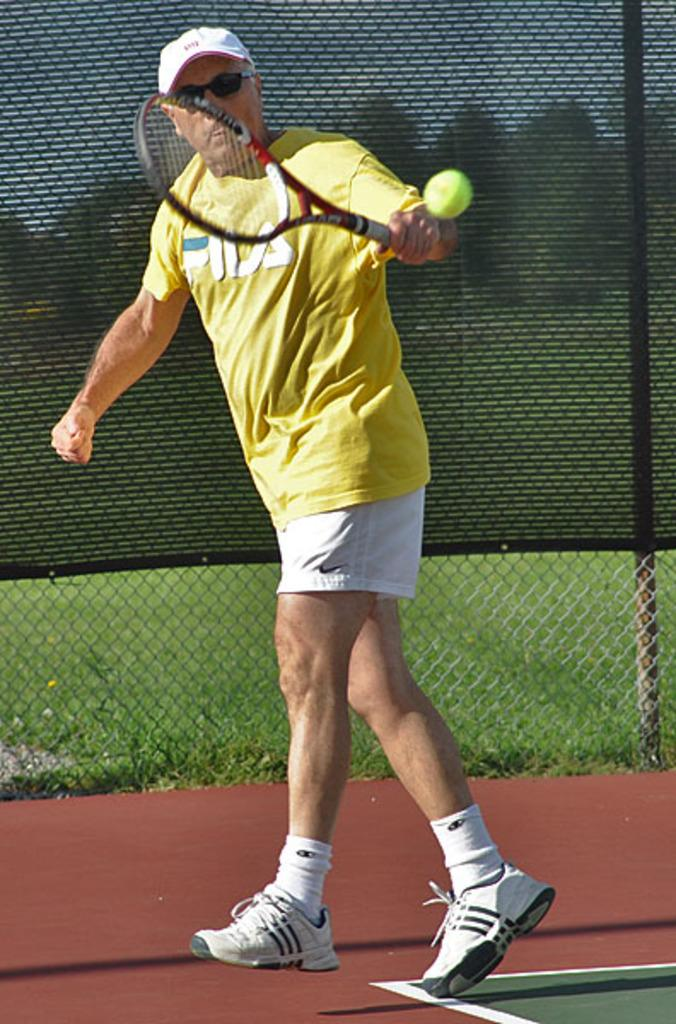What activity is the man in the image engaged in? The man is playing tennis. What type of eyewear is the man wearing? The man is wearing spectacles. What type of clothing is the man wearing on his upper body? The man is wearing a T-shirt. What type of headwear is the man wearing? The man is wearing a cap. What type of footwear is the man wearing? The man is wearing shoes. What type of cheese can be seen in the image? There is no cheese present in the image. 